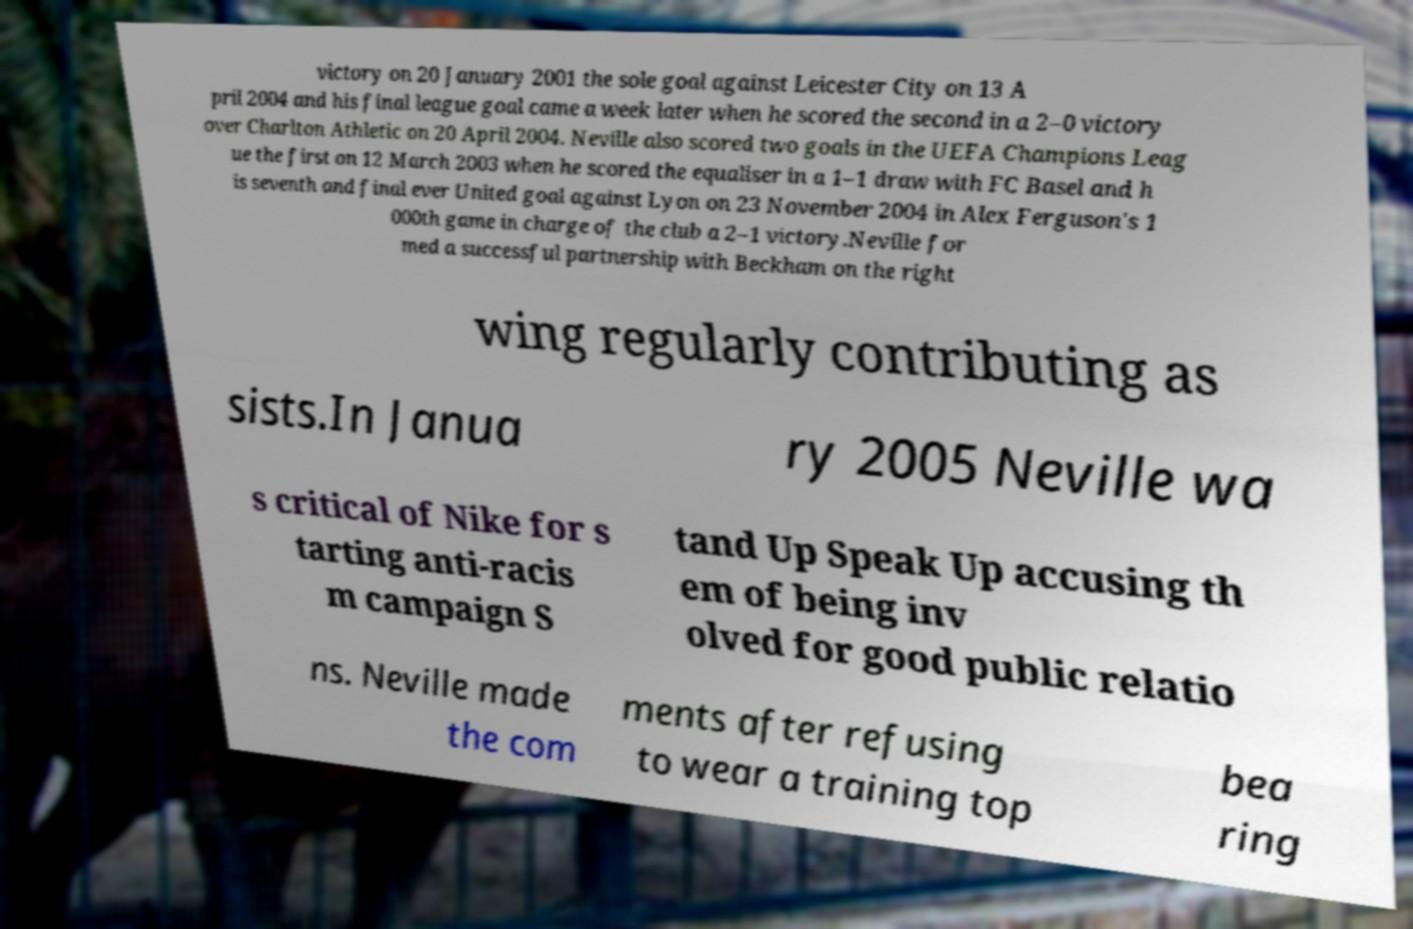I need the written content from this picture converted into text. Can you do that? victory on 20 January 2001 the sole goal against Leicester City on 13 A pril 2004 and his final league goal came a week later when he scored the second in a 2–0 victory over Charlton Athletic on 20 April 2004. Neville also scored two goals in the UEFA Champions Leag ue the first on 12 March 2003 when he scored the equaliser in a 1–1 draw with FC Basel and h is seventh and final ever United goal against Lyon on 23 November 2004 in Alex Ferguson's 1 000th game in charge of the club a 2–1 victory.Neville for med a successful partnership with Beckham on the right wing regularly contributing as sists.In Janua ry 2005 Neville wa s critical of Nike for s tarting anti-racis m campaign S tand Up Speak Up accusing th em of being inv olved for good public relatio ns. Neville made the com ments after refusing to wear a training top bea ring 